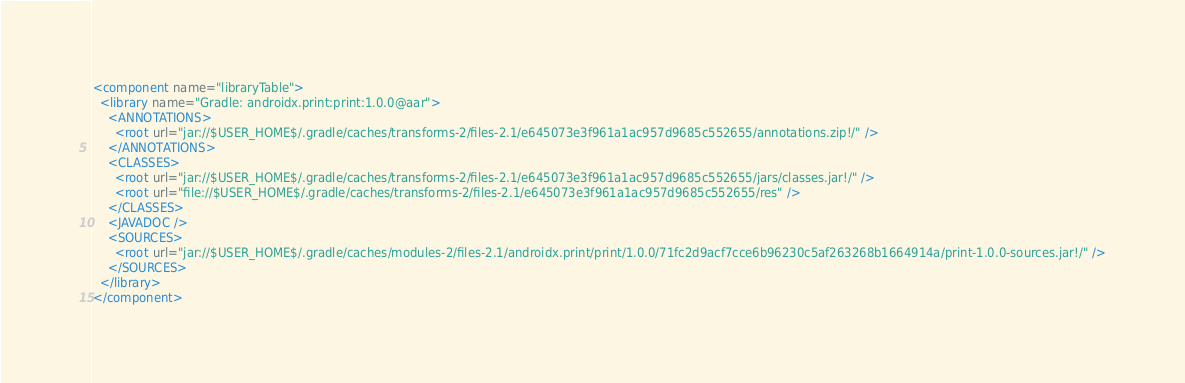<code> <loc_0><loc_0><loc_500><loc_500><_XML_><component name="libraryTable">
  <library name="Gradle: androidx.print:print:1.0.0@aar">
    <ANNOTATIONS>
      <root url="jar://$USER_HOME$/.gradle/caches/transforms-2/files-2.1/e645073e3f961a1ac957d9685c552655/annotations.zip!/" />
    </ANNOTATIONS>
    <CLASSES>
      <root url="jar://$USER_HOME$/.gradle/caches/transforms-2/files-2.1/e645073e3f961a1ac957d9685c552655/jars/classes.jar!/" />
      <root url="file://$USER_HOME$/.gradle/caches/transforms-2/files-2.1/e645073e3f961a1ac957d9685c552655/res" />
    </CLASSES>
    <JAVADOC />
    <SOURCES>
      <root url="jar://$USER_HOME$/.gradle/caches/modules-2/files-2.1/androidx.print/print/1.0.0/71fc2d9acf7cce6b96230c5af263268b1664914a/print-1.0.0-sources.jar!/" />
    </SOURCES>
  </library>
</component></code> 